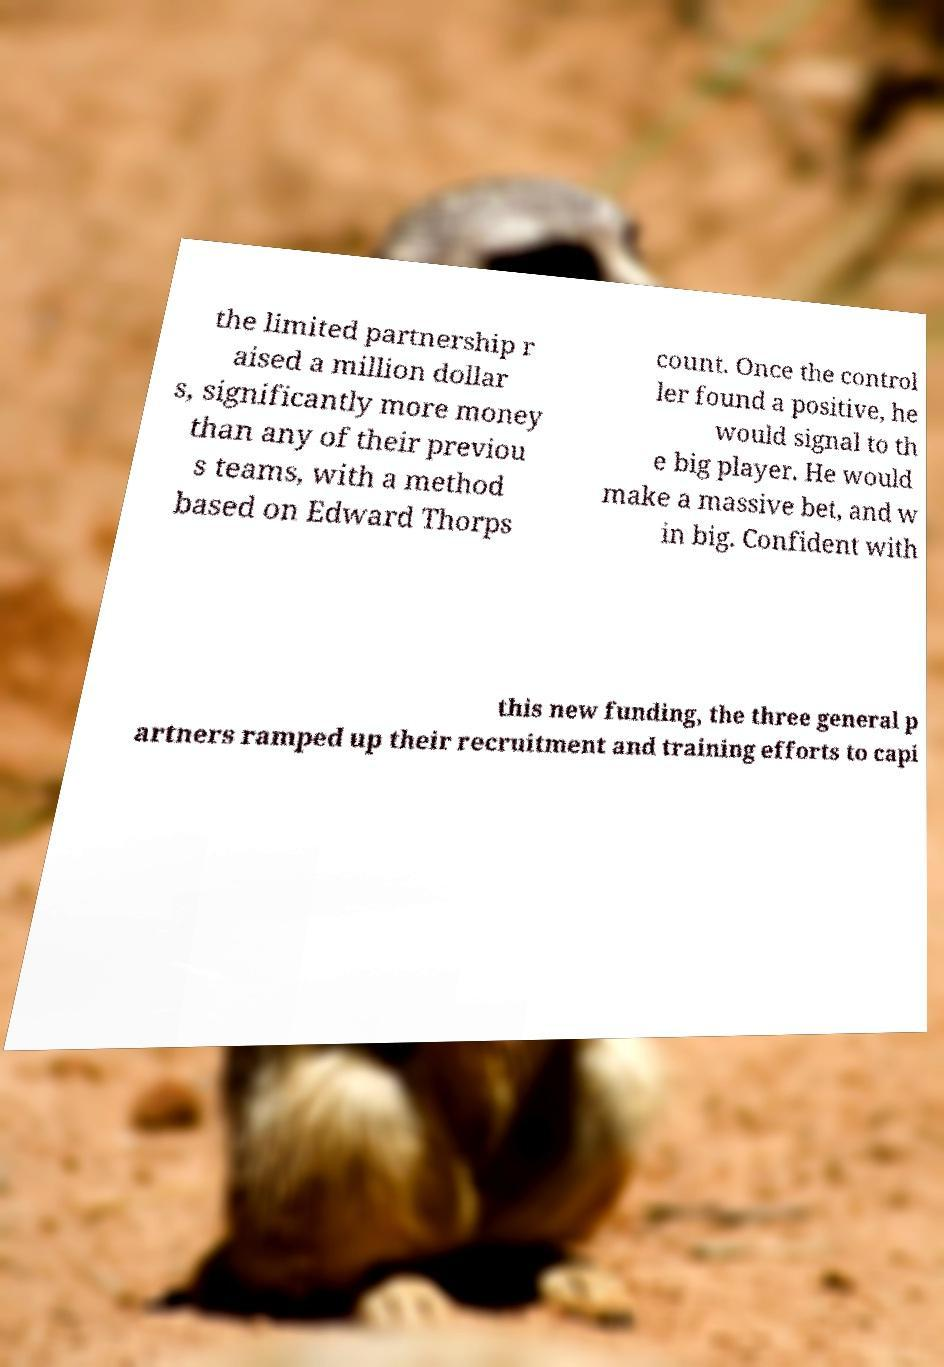Can you accurately transcribe the text from the provided image for me? the limited partnership r aised a million dollar s, significantly more money than any of their previou s teams, with a method based on Edward Thorps count. Once the control ler found a positive, he would signal to th e big player. He would make a massive bet, and w in big. Confident with this new funding, the three general p artners ramped up their recruitment and training efforts to capi 